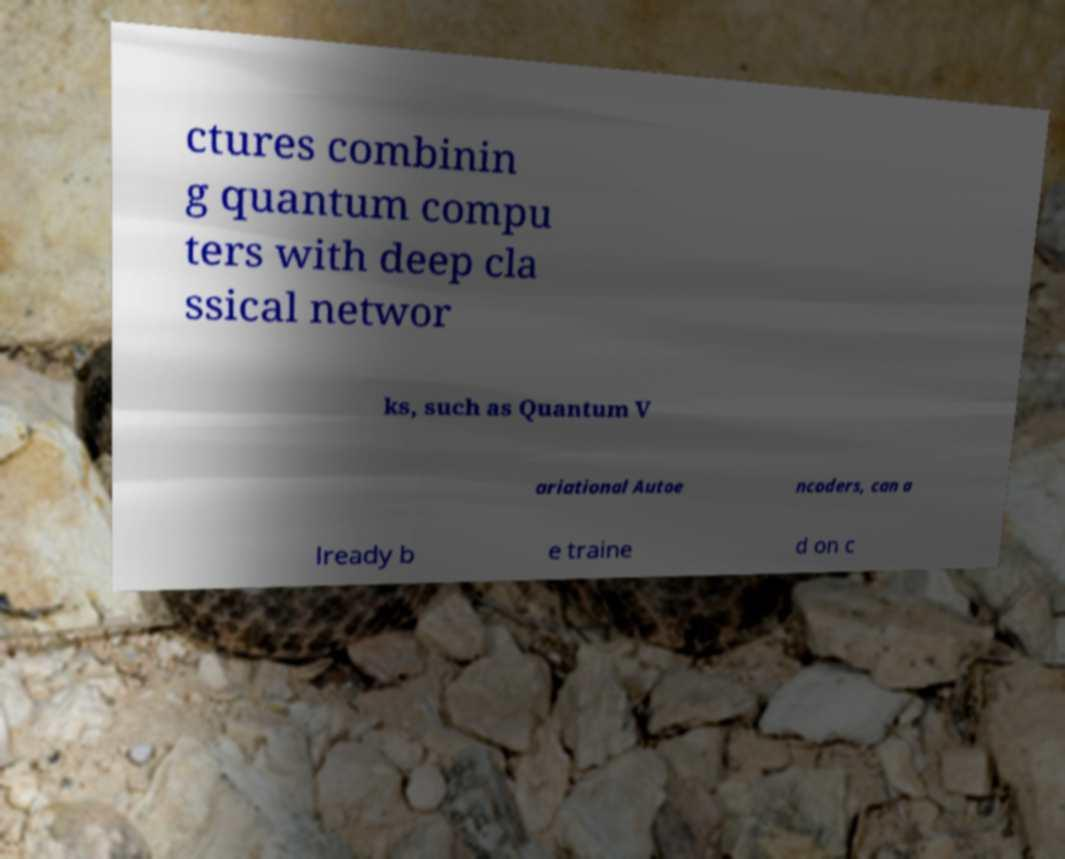Could you extract and type out the text from this image? ctures combinin g quantum compu ters with deep cla ssical networ ks, such as Quantum V ariational Autoe ncoders, can a lready b e traine d on c 